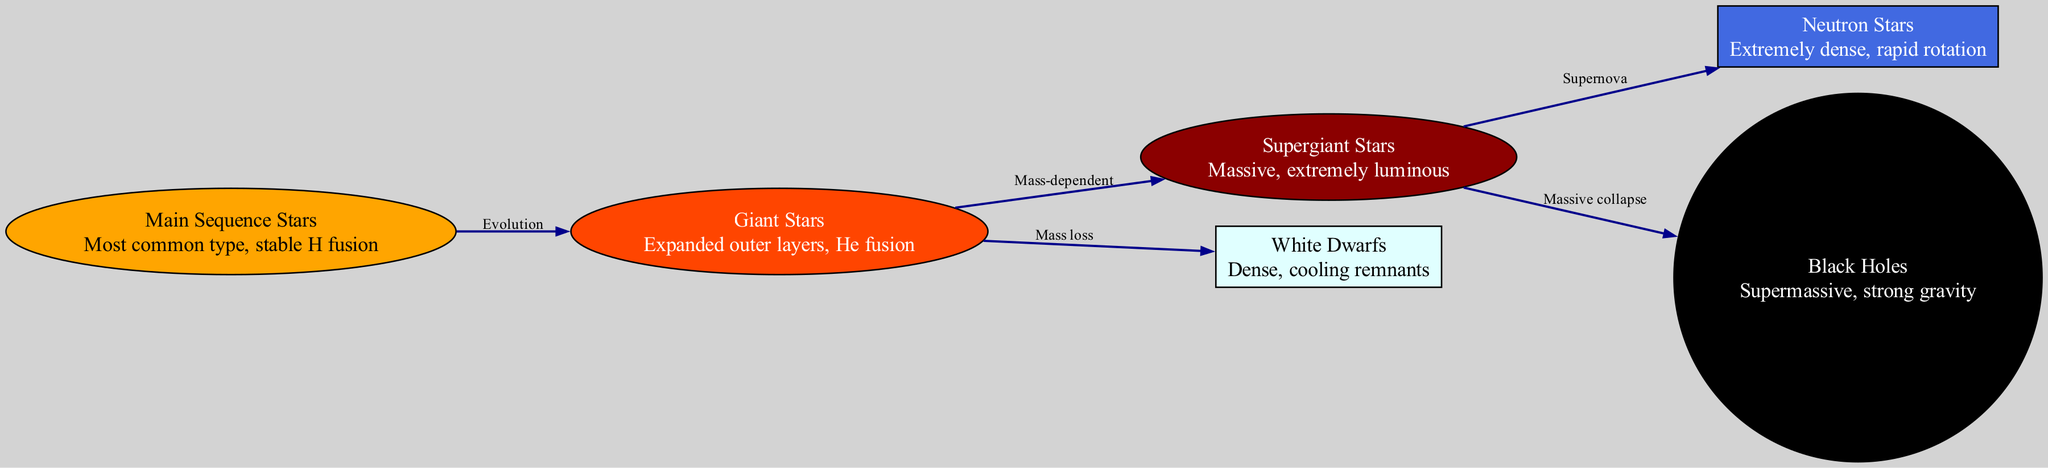What is the most common type of star? The diagram clearly identifies "Main Sequence Stars" as the most common type of star. This is explicitly stated in the properties of the corresponding node.
Answer: Main Sequence Stars How many types of stars are represented in the diagram? By counting the number of nodes listed in the data, we find there are six types of stars: Main Sequence Stars, Giant Stars, Supergiant Stars, White Dwarfs, Neutron Stars, and Black Holes.
Answer: Six What is the relationship between giant stars and white dwarfs? The diagram indicates an edge labeled "Mass loss" connecting "Giant Stars" to "White Dwarfs." This means that as Giant Stars lose mass, they can evolve into White Dwarfs.
Answer: Mass loss What happens to supergiant stars after a supernova? According to the edges in the diagram, supergiant stars can evolve into either Neutron Stars or Black Holes after a supernova, depending on their mass.
Answer: Neutron Stars or Black Holes Which type of stars are involved in the transition from giant to supergiant stars? The diagram shows an edge labeled "Mass-dependent" from "Giant Stars" to "Supergiant Stars," indicating that not all giants evolve to supergiants, but those that do have specific mass characteristics.
Answer: Mass-dependent What star type is characterized by "extremely dense, rapid rotation"? The node labeled "Neutron Stars" specifically describes this characteristic, making it clear which type of star this refers to.
Answer: Neutron Stars How many edges are there connecting the star types? By examining the edges defined in the data, we can count a total of five connections between the nodes, highlighting the relationships among the star classifications.
Answer: Five What are the two possible outcomes for supergiant stars, according to the diagram? The diagram shows edges leading to "Neutron Stars" and "Black Holes" from "Supergiant Stars," indicating these are the two outcomes based on the depicted evolution process.
Answer: Neutron Stars and Black Holes 